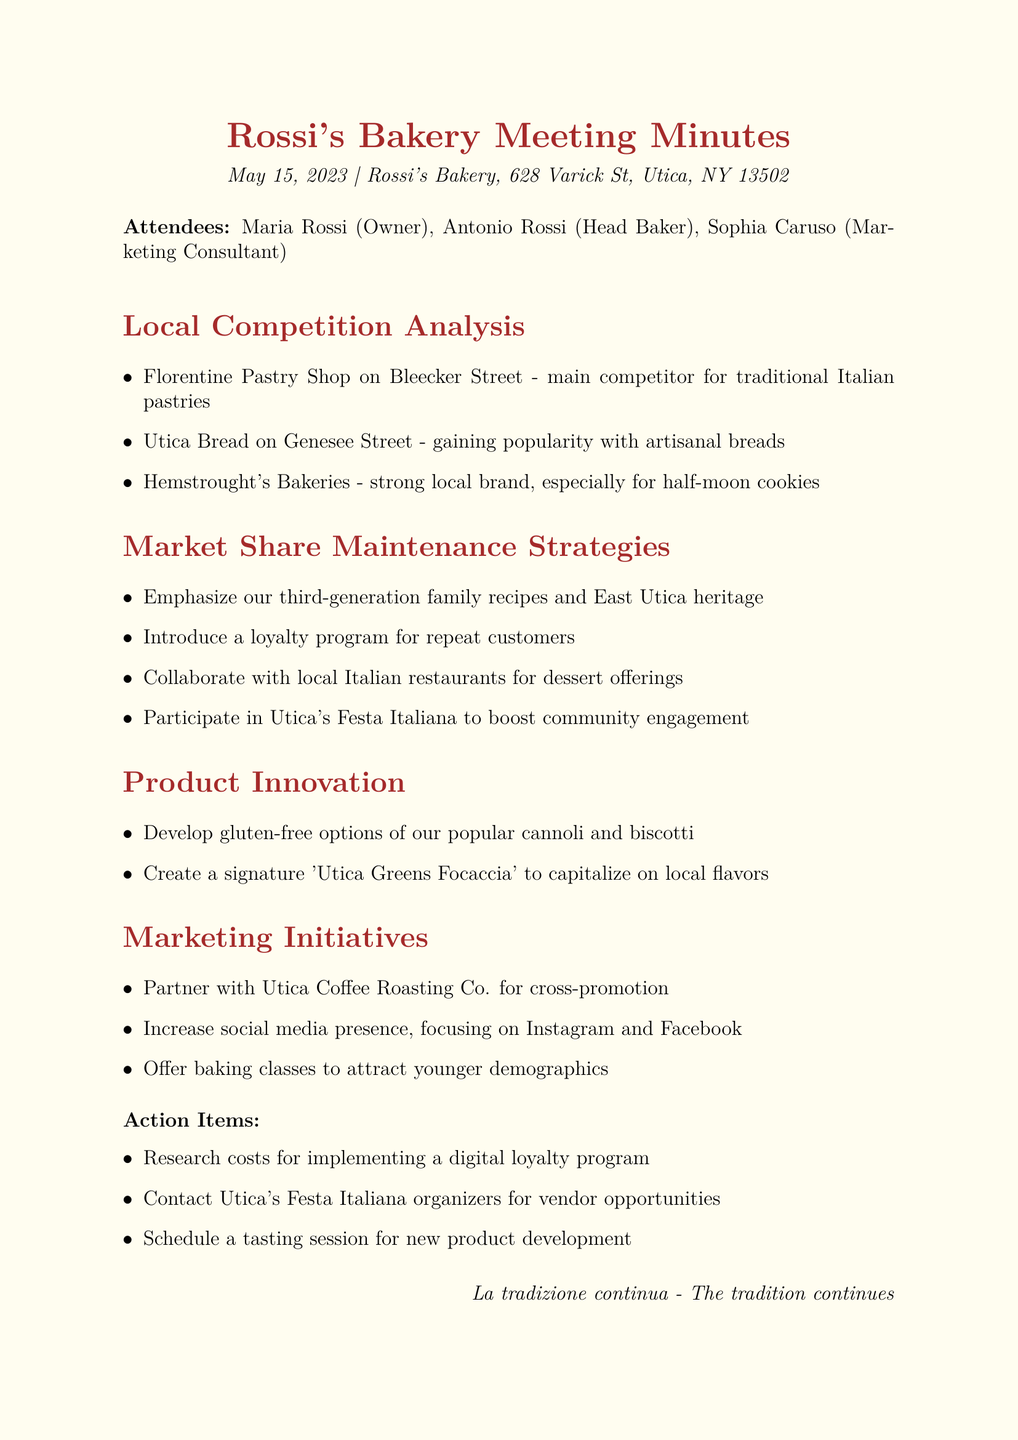What is the meeting title? The title of the meeting is explicitly stated at the beginning of the document, which is "Analysis of Local Competition and Market Share Strategies for Rossi's Bakery."
Answer: Analysis of Local Competition and Market Share Strategies for Rossi's Bakery Who are the attendees? The attendees are listed under the attendees section, which includes three individuals: Maria Rossi, Antonio Rossi, and Sophia Caruso.
Answer: Maria Rossi, Antonio Rossi, Sophia Caruso What is the date of the meeting? The date is provided at the start of the document, right after the meeting title.
Answer: May 15, 2023 Which bakery is identified as a main competitor for traditional Italian pastries? One of the agenda items mentions that the Florentine Pastry Shop is the main competitor for traditional Italian pastries.
Answer: Florentine Pastry Shop What is one strategy to maintain market share? The document lists various strategies, and one of them is to emphasize the third-generation family recipes and East Utica heritage.
Answer: Emphasize our third-generation family recipes and East Utica heritage How many action items are listed? The action items section lists three specific actions to be taken after the meeting.
Answer: 3 